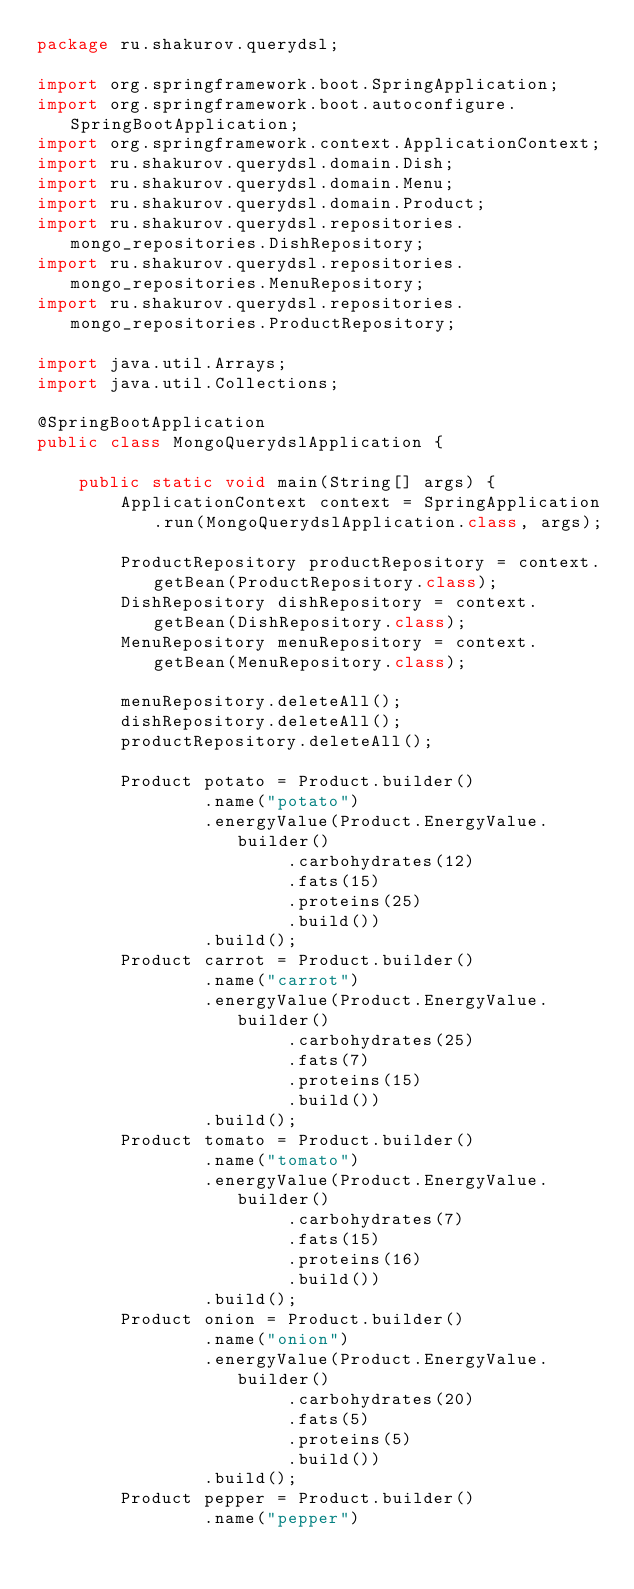<code> <loc_0><loc_0><loc_500><loc_500><_Java_>package ru.shakurov.querydsl;

import org.springframework.boot.SpringApplication;
import org.springframework.boot.autoconfigure.SpringBootApplication;
import org.springframework.context.ApplicationContext;
import ru.shakurov.querydsl.domain.Dish;
import ru.shakurov.querydsl.domain.Menu;
import ru.shakurov.querydsl.domain.Product;
import ru.shakurov.querydsl.repositories.mongo_repositories.DishRepository;
import ru.shakurov.querydsl.repositories.mongo_repositories.MenuRepository;
import ru.shakurov.querydsl.repositories.mongo_repositories.ProductRepository;

import java.util.Arrays;
import java.util.Collections;

@SpringBootApplication
public class MongoQuerydslApplication {

    public static void main(String[] args) {
        ApplicationContext context = SpringApplication.run(MongoQuerydslApplication.class, args);

        ProductRepository productRepository = context.getBean(ProductRepository.class);
        DishRepository dishRepository = context.getBean(DishRepository.class);
        MenuRepository menuRepository = context.getBean(MenuRepository.class);

        menuRepository.deleteAll();
        dishRepository.deleteAll();
        productRepository.deleteAll();

        Product potato = Product.builder()
                .name("potato")
                .energyValue(Product.EnergyValue.builder()
                        .carbohydrates(12)
                        .fats(15)
                        .proteins(25)
                        .build())
                .build();
        Product carrot = Product.builder()
                .name("carrot")
                .energyValue(Product.EnergyValue.builder()
                        .carbohydrates(25)
                        .fats(7)
                        .proteins(15)
                        .build())
                .build();
        Product tomato = Product.builder()
                .name("tomato")
                .energyValue(Product.EnergyValue.builder()
                        .carbohydrates(7)
                        .fats(15)
                        .proteins(16)
                        .build())
                .build();
        Product onion = Product.builder()
                .name("onion")
                .energyValue(Product.EnergyValue.builder()
                        .carbohydrates(20)
                        .fats(5)
                        .proteins(5)
                        .build())
                .build();
        Product pepper = Product.builder()
                .name("pepper")</code> 